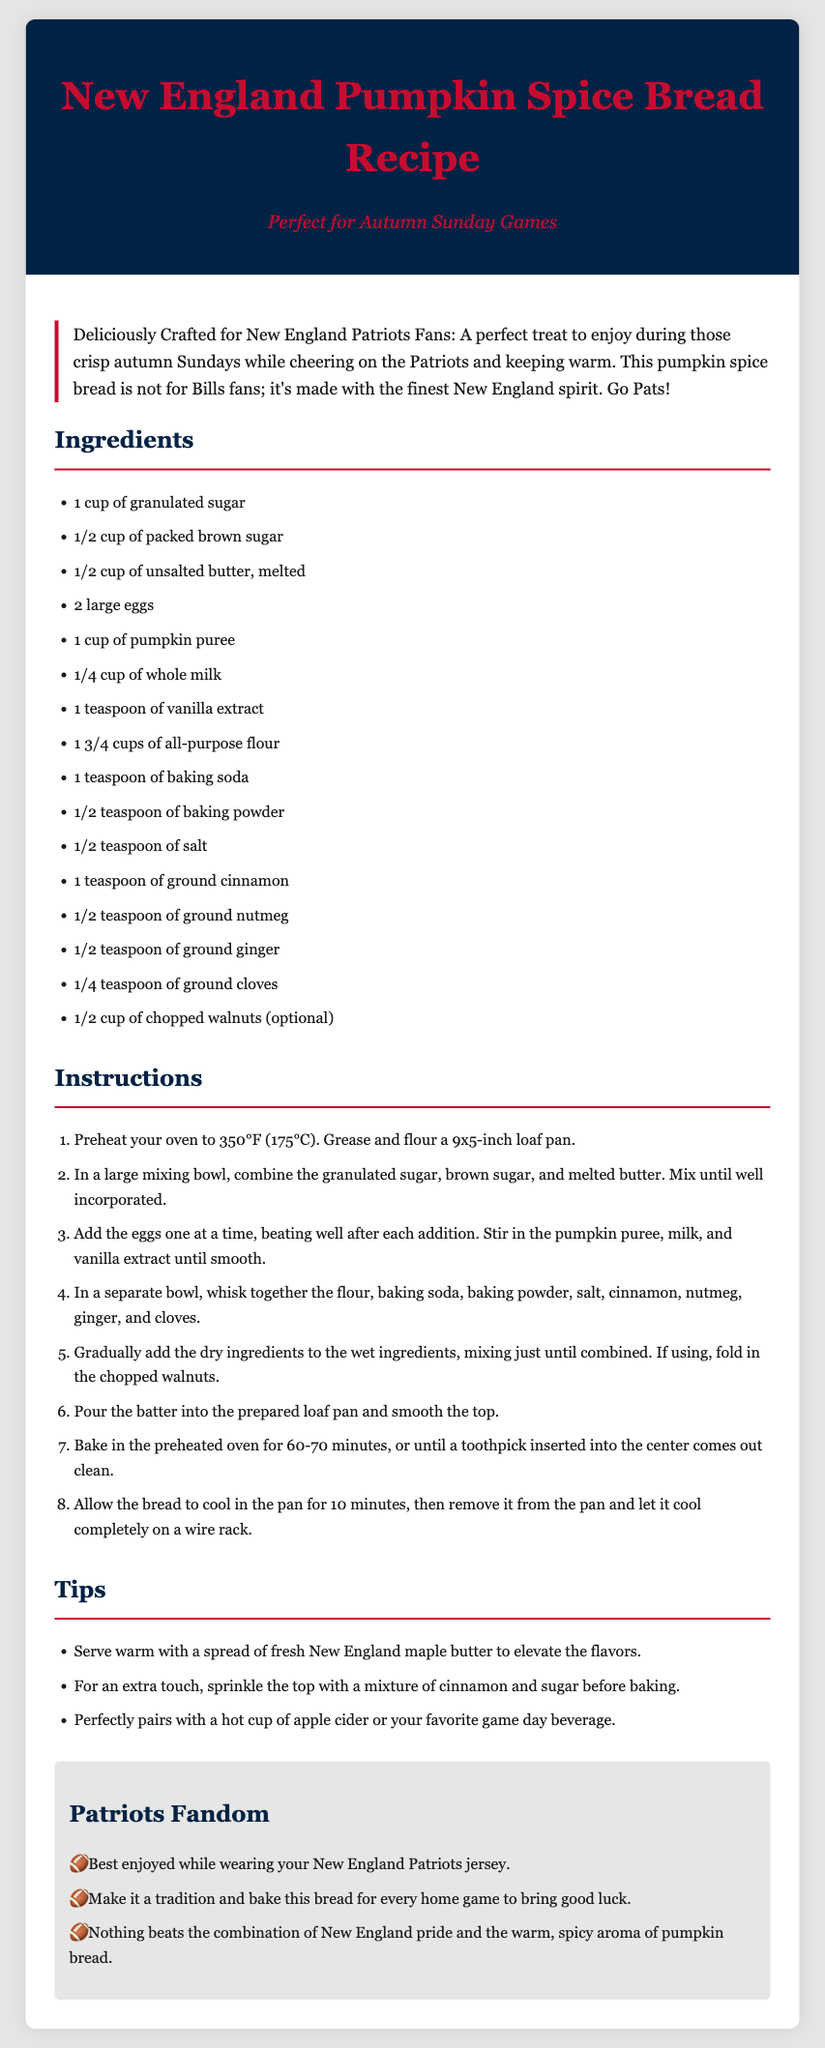what is the main ingredient in the recipe? The main ingredient in the recipe is pumpkin puree.
Answer: pumpkin puree how long should the bread be baked? The bread should be baked for 60-70 minutes.
Answer: 60-70 minutes what type of nuts is optional in the recipe? The nuts mentioned as optional in the recipe are walnuts.
Answer: walnuts what is a suggested pairing for the bread? A suggested pairing for the bread is apple cider.
Answer: apple cider what color is the recipe header background? The recipe header background color is dark blue (#002244).
Answer: dark blue how many eggs are used in the recipe? The recipe calls for 2 large eggs.
Answer: 2 large eggs what is the description of the bread meant to convey? The description conveys that it's perfect for New England Patriots fans during autumn games.
Answer: perfect for New England Patriots fans what should you serve with the bread to enhance its flavor? You should serve it with fresh New England maple butter.
Answer: fresh New England maple butter what is emphasized for the fans in the recipe? It emphasizes wearing a New England Patriots jersey while enjoying the bread.
Answer: wearing a New England Patriots jersey 